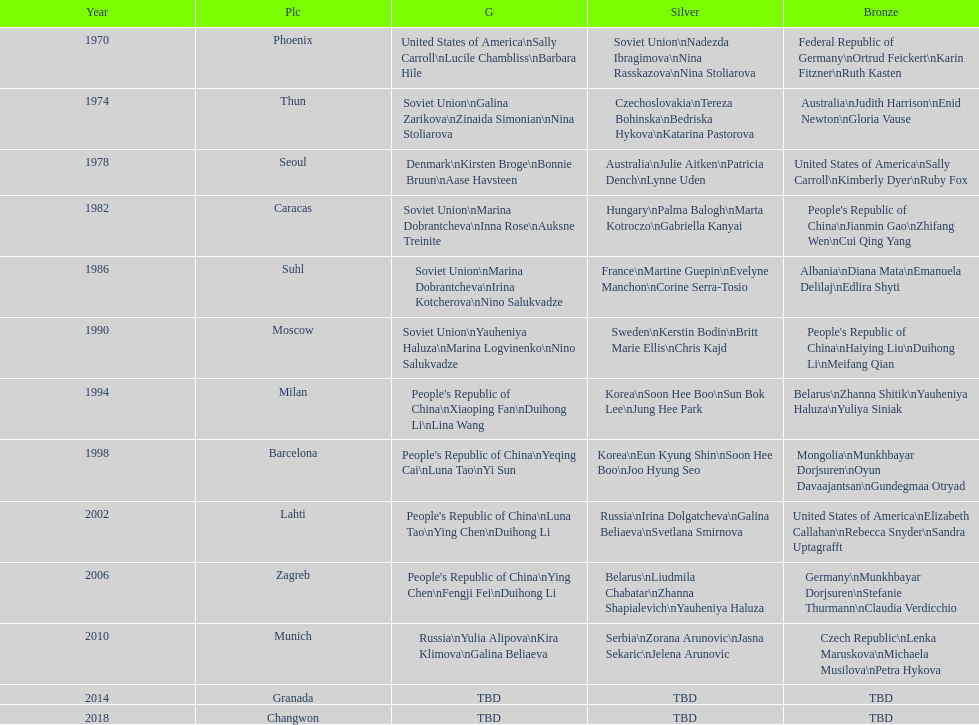Whose name is listed before bonnie bruun's in the gold column? Kirsten Broge. 